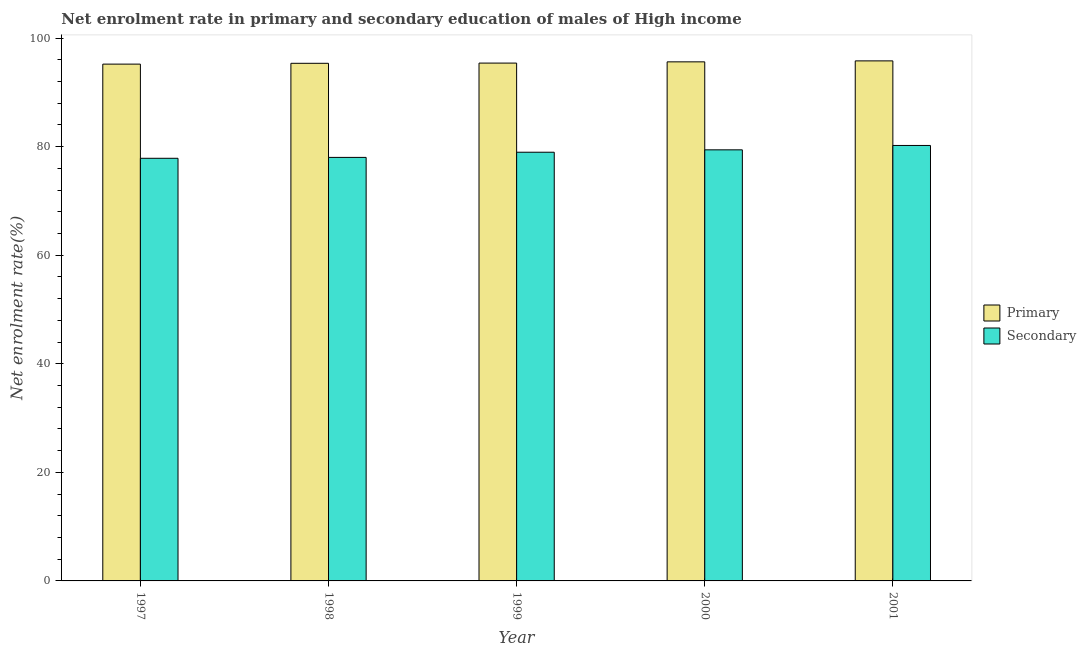Are the number of bars on each tick of the X-axis equal?
Offer a very short reply. Yes. What is the enrollment rate in secondary education in 2000?
Make the answer very short. 79.42. Across all years, what is the maximum enrollment rate in primary education?
Offer a terse response. 95.81. Across all years, what is the minimum enrollment rate in primary education?
Keep it short and to the point. 95.22. In which year was the enrollment rate in secondary education maximum?
Your answer should be compact. 2001. What is the total enrollment rate in primary education in the graph?
Offer a terse response. 477.44. What is the difference between the enrollment rate in primary education in 2000 and that in 2001?
Offer a terse response. -0.18. What is the difference between the enrollment rate in secondary education in 1998 and the enrollment rate in primary education in 2000?
Ensure brevity in your answer.  -1.39. What is the average enrollment rate in secondary education per year?
Offer a terse response. 78.91. What is the ratio of the enrollment rate in primary education in 1998 to that in 2001?
Provide a short and direct response. 1. Is the enrollment rate in secondary education in 1997 less than that in 1999?
Your response must be concise. Yes. What is the difference between the highest and the second highest enrollment rate in primary education?
Your response must be concise. 0.18. What is the difference between the highest and the lowest enrollment rate in primary education?
Give a very brief answer. 0.6. What does the 2nd bar from the left in 2000 represents?
Your answer should be compact. Secondary. What does the 1st bar from the right in 1998 represents?
Keep it short and to the point. Secondary. Are all the bars in the graph horizontal?
Keep it short and to the point. No. Does the graph contain any zero values?
Keep it short and to the point. No. How many legend labels are there?
Offer a terse response. 2. How are the legend labels stacked?
Keep it short and to the point. Vertical. What is the title of the graph?
Provide a succinct answer. Net enrolment rate in primary and secondary education of males of High income. Does "Quality of trade" appear as one of the legend labels in the graph?
Give a very brief answer. No. What is the label or title of the Y-axis?
Offer a very short reply. Net enrolment rate(%). What is the Net enrolment rate(%) of Primary in 1997?
Ensure brevity in your answer.  95.22. What is the Net enrolment rate(%) of Secondary in 1997?
Provide a short and direct response. 77.87. What is the Net enrolment rate(%) of Primary in 1998?
Keep it short and to the point. 95.37. What is the Net enrolment rate(%) in Secondary in 1998?
Provide a succinct answer. 78.03. What is the Net enrolment rate(%) in Primary in 1999?
Give a very brief answer. 95.41. What is the Net enrolment rate(%) in Secondary in 1999?
Provide a succinct answer. 78.98. What is the Net enrolment rate(%) in Primary in 2000?
Your response must be concise. 95.63. What is the Net enrolment rate(%) of Secondary in 2000?
Give a very brief answer. 79.42. What is the Net enrolment rate(%) in Primary in 2001?
Offer a terse response. 95.81. What is the Net enrolment rate(%) in Secondary in 2001?
Offer a very short reply. 80.23. Across all years, what is the maximum Net enrolment rate(%) of Primary?
Your answer should be compact. 95.81. Across all years, what is the maximum Net enrolment rate(%) in Secondary?
Offer a very short reply. 80.23. Across all years, what is the minimum Net enrolment rate(%) of Primary?
Your response must be concise. 95.22. Across all years, what is the minimum Net enrolment rate(%) in Secondary?
Provide a short and direct response. 77.87. What is the total Net enrolment rate(%) in Primary in the graph?
Provide a succinct answer. 477.44. What is the total Net enrolment rate(%) in Secondary in the graph?
Offer a terse response. 394.54. What is the difference between the Net enrolment rate(%) of Primary in 1997 and that in 1998?
Offer a very short reply. -0.15. What is the difference between the Net enrolment rate(%) of Secondary in 1997 and that in 1998?
Offer a very short reply. -0.16. What is the difference between the Net enrolment rate(%) in Primary in 1997 and that in 1999?
Give a very brief answer. -0.19. What is the difference between the Net enrolment rate(%) of Secondary in 1997 and that in 1999?
Your response must be concise. -1.12. What is the difference between the Net enrolment rate(%) in Primary in 1997 and that in 2000?
Your response must be concise. -0.42. What is the difference between the Net enrolment rate(%) of Secondary in 1997 and that in 2000?
Your response must be concise. -1.56. What is the difference between the Net enrolment rate(%) of Primary in 1997 and that in 2001?
Your response must be concise. -0.6. What is the difference between the Net enrolment rate(%) in Secondary in 1997 and that in 2001?
Provide a short and direct response. -2.36. What is the difference between the Net enrolment rate(%) of Primary in 1998 and that in 1999?
Ensure brevity in your answer.  -0.04. What is the difference between the Net enrolment rate(%) in Secondary in 1998 and that in 1999?
Your answer should be very brief. -0.95. What is the difference between the Net enrolment rate(%) of Primary in 1998 and that in 2000?
Your answer should be very brief. -0.27. What is the difference between the Net enrolment rate(%) of Secondary in 1998 and that in 2000?
Provide a short and direct response. -1.39. What is the difference between the Net enrolment rate(%) in Primary in 1998 and that in 2001?
Your answer should be very brief. -0.45. What is the difference between the Net enrolment rate(%) of Secondary in 1998 and that in 2001?
Your response must be concise. -2.2. What is the difference between the Net enrolment rate(%) of Primary in 1999 and that in 2000?
Keep it short and to the point. -0.23. What is the difference between the Net enrolment rate(%) of Secondary in 1999 and that in 2000?
Your answer should be compact. -0.44. What is the difference between the Net enrolment rate(%) in Primary in 1999 and that in 2001?
Your response must be concise. -0.41. What is the difference between the Net enrolment rate(%) of Secondary in 1999 and that in 2001?
Give a very brief answer. -1.25. What is the difference between the Net enrolment rate(%) in Primary in 2000 and that in 2001?
Offer a terse response. -0.18. What is the difference between the Net enrolment rate(%) of Secondary in 2000 and that in 2001?
Offer a terse response. -0.81. What is the difference between the Net enrolment rate(%) of Primary in 1997 and the Net enrolment rate(%) of Secondary in 1998?
Ensure brevity in your answer.  17.18. What is the difference between the Net enrolment rate(%) in Primary in 1997 and the Net enrolment rate(%) in Secondary in 1999?
Ensure brevity in your answer.  16.23. What is the difference between the Net enrolment rate(%) of Primary in 1997 and the Net enrolment rate(%) of Secondary in 2000?
Make the answer very short. 15.79. What is the difference between the Net enrolment rate(%) of Primary in 1997 and the Net enrolment rate(%) of Secondary in 2001?
Make the answer very short. 14.99. What is the difference between the Net enrolment rate(%) in Primary in 1998 and the Net enrolment rate(%) in Secondary in 1999?
Offer a terse response. 16.38. What is the difference between the Net enrolment rate(%) in Primary in 1998 and the Net enrolment rate(%) in Secondary in 2000?
Offer a very short reply. 15.94. What is the difference between the Net enrolment rate(%) of Primary in 1998 and the Net enrolment rate(%) of Secondary in 2001?
Your answer should be very brief. 15.14. What is the difference between the Net enrolment rate(%) in Primary in 1999 and the Net enrolment rate(%) in Secondary in 2000?
Your answer should be compact. 15.98. What is the difference between the Net enrolment rate(%) of Primary in 1999 and the Net enrolment rate(%) of Secondary in 2001?
Provide a short and direct response. 15.18. What is the difference between the Net enrolment rate(%) in Primary in 2000 and the Net enrolment rate(%) in Secondary in 2001?
Give a very brief answer. 15.4. What is the average Net enrolment rate(%) of Primary per year?
Your response must be concise. 95.49. What is the average Net enrolment rate(%) in Secondary per year?
Your answer should be compact. 78.91. In the year 1997, what is the difference between the Net enrolment rate(%) of Primary and Net enrolment rate(%) of Secondary?
Give a very brief answer. 17.35. In the year 1998, what is the difference between the Net enrolment rate(%) of Primary and Net enrolment rate(%) of Secondary?
Offer a very short reply. 17.33. In the year 1999, what is the difference between the Net enrolment rate(%) of Primary and Net enrolment rate(%) of Secondary?
Make the answer very short. 16.42. In the year 2000, what is the difference between the Net enrolment rate(%) in Primary and Net enrolment rate(%) in Secondary?
Offer a terse response. 16.21. In the year 2001, what is the difference between the Net enrolment rate(%) in Primary and Net enrolment rate(%) in Secondary?
Ensure brevity in your answer.  15.58. What is the ratio of the Net enrolment rate(%) in Primary in 1997 to that in 1998?
Your response must be concise. 1. What is the ratio of the Net enrolment rate(%) of Secondary in 1997 to that in 1998?
Your response must be concise. 1. What is the ratio of the Net enrolment rate(%) of Primary in 1997 to that in 1999?
Keep it short and to the point. 1. What is the ratio of the Net enrolment rate(%) of Secondary in 1997 to that in 1999?
Provide a succinct answer. 0.99. What is the ratio of the Net enrolment rate(%) of Secondary in 1997 to that in 2000?
Provide a succinct answer. 0.98. What is the ratio of the Net enrolment rate(%) in Secondary in 1997 to that in 2001?
Keep it short and to the point. 0.97. What is the ratio of the Net enrolment rate(%) in Primary in 1998 to that in 1999?
Give a very brief answer. 1. What is the ratio of the Net enrolment rate(%) in Secondary in 1998 to that in 1999?
Give a very brief answer. 0.99. What is the ratio of the Net enrolment rate(%) in Secondary in 1998 to that in 2000?
Keep it short and to the point. 0.98. What is the ratio of the Net enrolment rate(%) of Secondary in 1998 to that in 2001?
Your answer should be compact. 0.97. What is the ratio of the Net enrolment rate(%) of Secondary in 1999 to that in 2001?
Offer a very short reply. 0.98. What is the ratio of the Net enrolment rate(%) in Primary in 2000 to that in 2001?
Provide a succinct answer. 1. What is the difference between the highest and the second highest Net enrolment rate(%) of Primary?
Your answer should be compact. 0.18. What is the difference between the highest and the second highest Net enrolment rate(%) of Secondary?
Provide a short and direct response. 0.81. What is the difference between the highest and the lowest Net enrolment rate(%) in Primary?
Your answer should be compact. 0.6. What is the difference between the highest and the lowest Net enrolment rate(%) of Secondary?
Offer a very short reply. 2.36. 